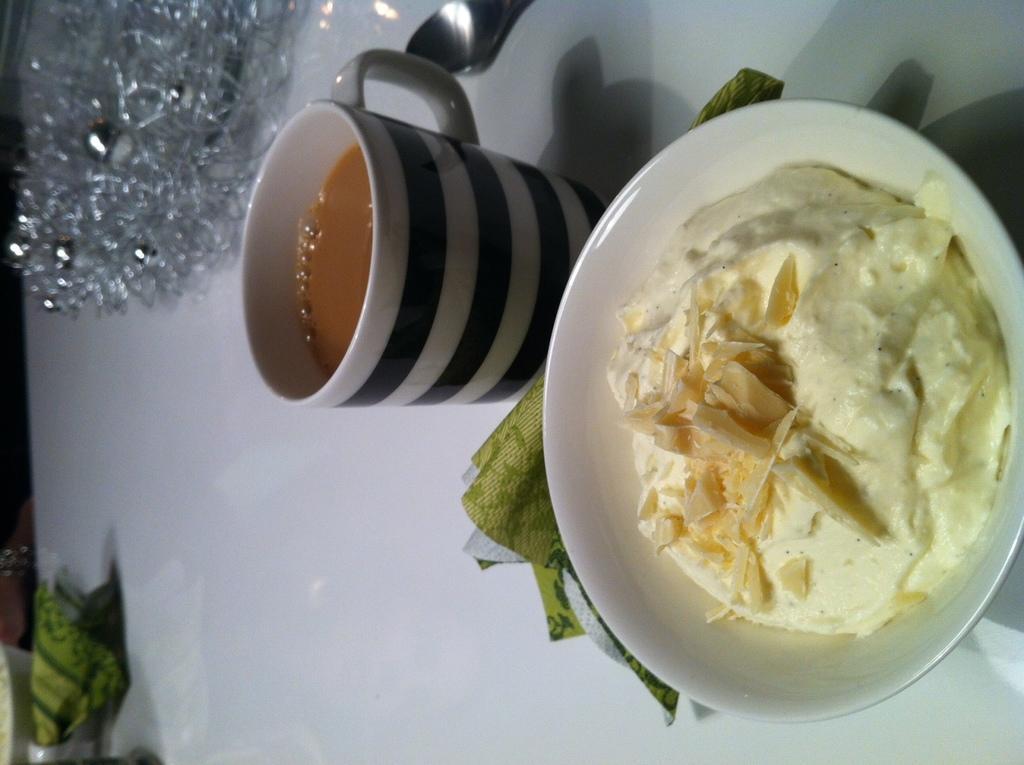Please provide a concise description of this image. In this image there is a table. There are tea cup and bowl with food. There are other objects. 